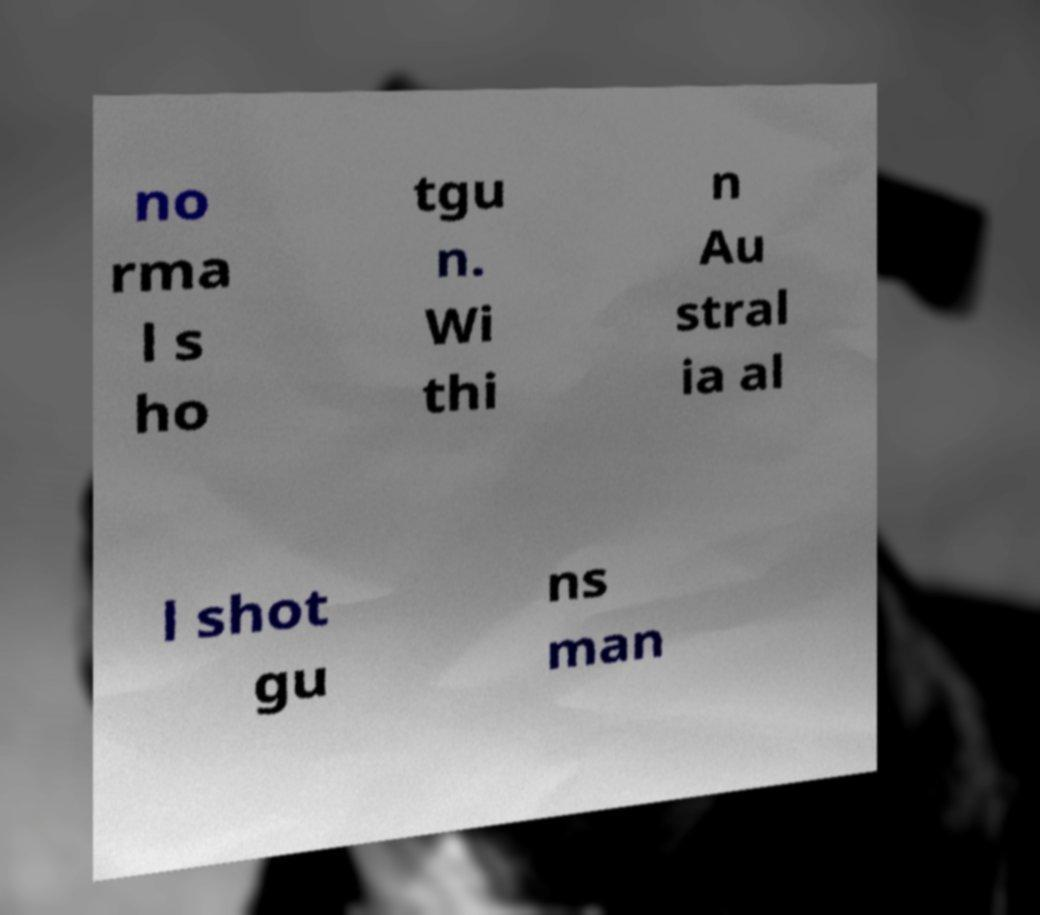Please read and relay the text visible in this image. What does it say? no rma l s ho tgu n. Wi thi n Au stral ia al l shot gu ns man 